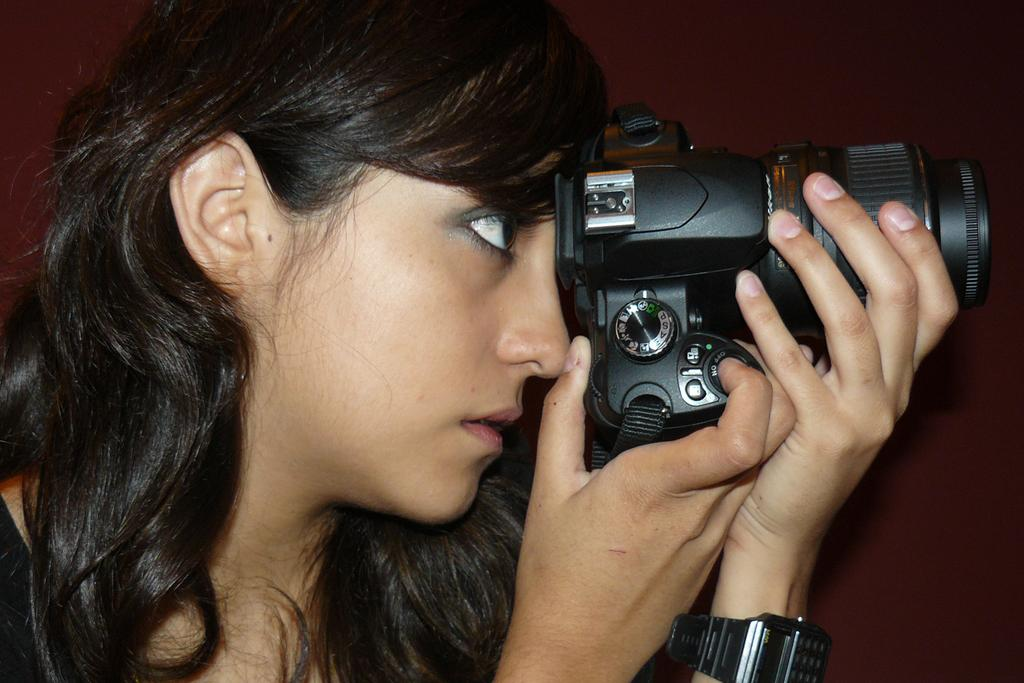Who is the main subject in the image? There is a woman in the image. What is the woman holding in the image? The woman is holding a camera. What accessory is the woman wearing in the image? The woman is wearing a watch on her hand. What flavor of coat is the woman wearing in the image? There is no coat present in the image, so it is not possible to determine the flavor. 